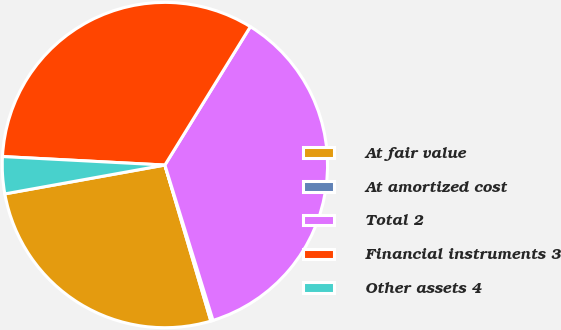Convert chart to OTSL. <chart><loc_0><loc_0><loc_500><loc_500><pie_chart><fcel>At fair value<fcel>At amortized cost<fcel>Total 2<fcel>Financial instruments 3<fcel>Other assets 4<nl><fcel>26.72%<fcel>0.22%<fcel>36.41%<fcel>32.97%<fcel>3.67%<nl></chart> 